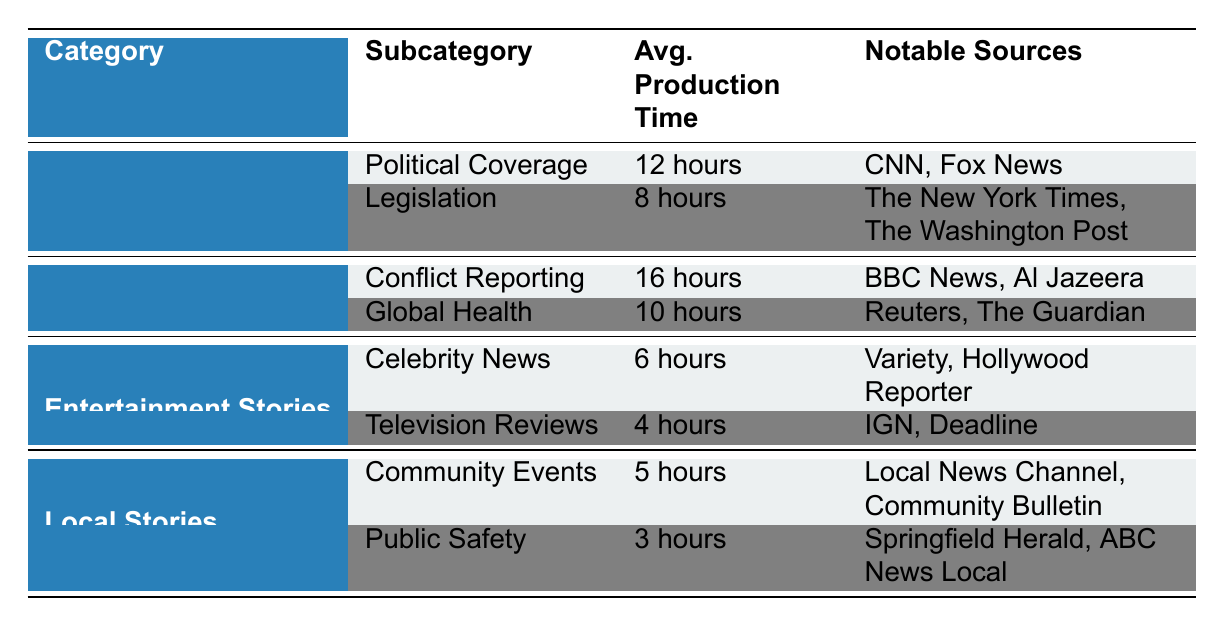What is the average production time for Political Coverage? The table indicates that the average production time for Political Coverage, specifically for the title "2023 U.S. Presidential Election Debates," is listed as 12 hours.
Answer: 12 hours Which category has the quickest average production time? By examining the average production times across all categories, the quickest production time is for "Television Reviews" under Entertainment Stories, which takes 4 hours.
Answer: Entertainment Stories True or False: The title "COVID-19 Vaccine Rollout in Africa" has a longer average production time than "Oscars 2023: Winners and Highlights". The average production time for "COVID-19 Vaccine Rollout in Africa" is 10 hours, while "Oscars 2023: Winners and Highlights" is 6 hours; therefore, the statement is true.
Answer: True What is the total average production time for International Stories? To calculate the total average production time for International Stories, we add the times for "Conflict in Ukraine: A Year Later" (16 hours) and "COVID-19 Vaccine Rollout in Africa" (10 hours), which gives us 26 hours.
Answer: 26 hours How many notable sources are mentioned for Local Stories? The notable sources listed for Local Stories include "Local News Channel" and "Community Bulletin" for Community Events, and "Springfield Herald" and "ABC News Local" for Public Safety. This totals to four notable sources for the category.
Answer: 4 Which subcategory in National Stories has the shortest average production time? In the National Stories category, "Legislation" with "The Inflation Reduction Act Analysis" has an average production time of 8 hours, which is shorter than Political Coverage, which is 12 hours.
Answer: Legislation What is the difference in average production time between the longest and shortest stories in the table? The longest average production time is for "Conflict Reporting" (16 hours) in International Stories and the shortest is for "Public Safety" (3 hours) in Local Stories. The difference is calculated as 16 - 3 = 13 hours.
Answer: 13 hours Is the average production time for Community Events greater than 5 hours? The average production time for "Community Events" is listed as 5 hours, which is not greater than 5. Thus, the answer to the question is no.
Answer: No 